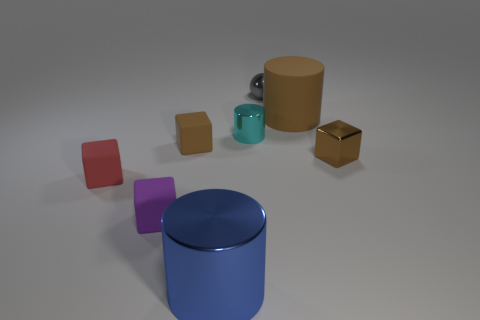Subtract all blue cylinders. Subtract all purple balls. How many cylinders are left? 2 Add 1 large green objects. How many objects exist? 9 Subtract all cylinders. How many objects are left? 5 Subtract all small brown objects. Subtract all rubber cylinders. How many objects are left? 5 Add 7 large brown things. How many large brown things are left? 8 Add 8 red things. How many red things exist? 9 Subtract 1 purple cubes. How many objects are left? 7 